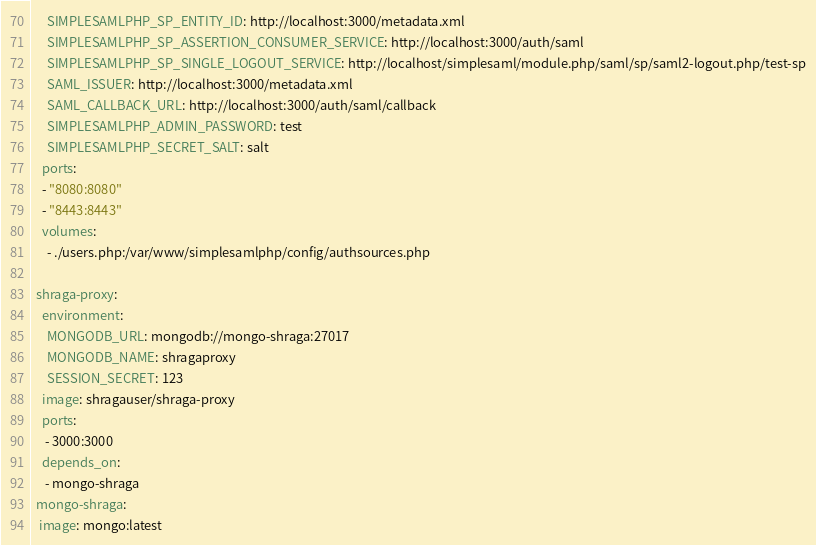<code> <loc_0><loc_0><loc_500><loc_500><_YAML_>      SIMPLESAMLPHP_SP_ENTITY_ID: http://localhost:3000/metadata.xml
      SIMPLESAMLPHP_SP_ASSERTION_CONSUMER_SERVICE: http://localhost:3000/auth/saml
      SIMPLESAMLPHP_SP_SINGLE_LOGOUT_SERVICE: http://localhost/simplesaml/module.php/saml/sp/saml2-logout.php/test-sp
      SAML_ISSUER: http://localhost:3000/metadata.xml
      SAML_CALLBACK_URL: http://localhost:3000/auth/saml/callback
      SIMPLESAMLPHP_ADMIN_PASSWORD: test
      SIMPLESAMLPHP_SECRET_SALT: salt
    ports:
    - "8080:8080"
    - "8443:8443"
    volumes:
      - ./users.php:/var/www/simplesamlphp/config/authsources.php

  shraga-proxy:
    environment: 
      MONGODB_URL: mongodb://mongo-shraga:27017
      MONGODB_NAME: shragaproxy
      SESSION_SECRET: 123
    image: shragauser/shraga-proxy
    ports:
     - 3000:3000
    depends_on:
     - mongo-shraga
  mongo-shraga:
   image: mongo:latest</code> 